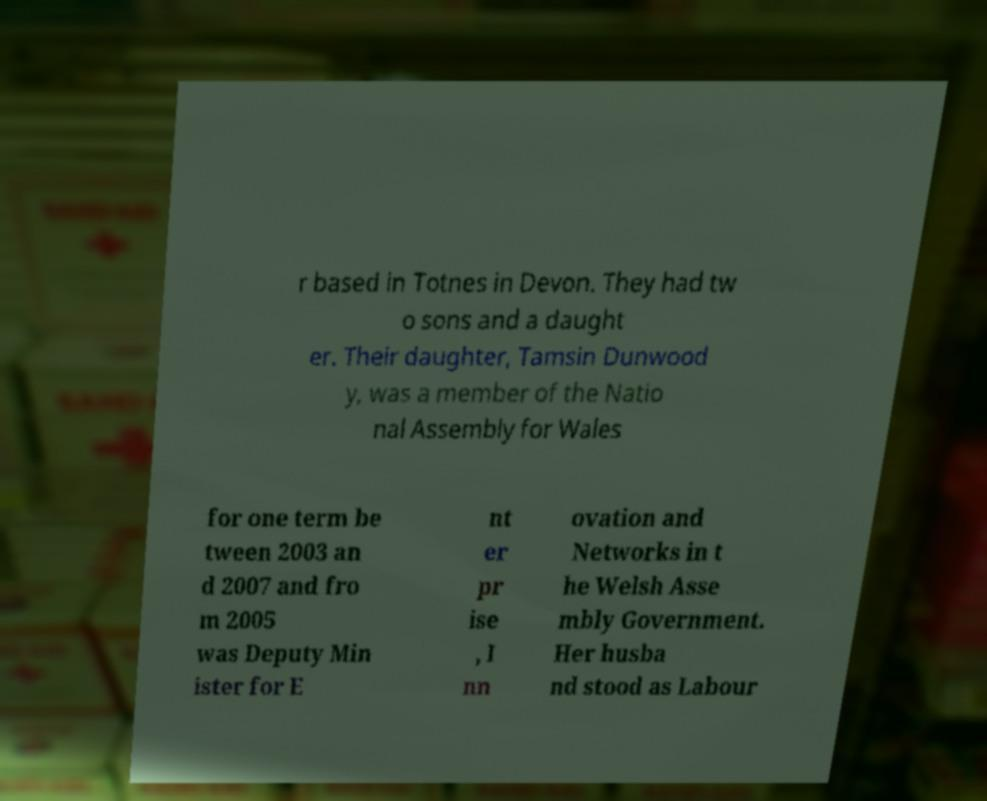Please read and relay the text visible in this image. What does it say? r based in Totnes in Devon. They had tw o sons and a daught er. Their daughter, Tamsin Dunwood y, was a member of the Natio nal Assembly for Wales for one term be tween 2003 an d 2007 and fro m 2005 was Deputy Min ister for E nt er pr ise , I nn ovation and Networks in t he Welsh Asse mbly Government. Her husba nd stood as Labour 